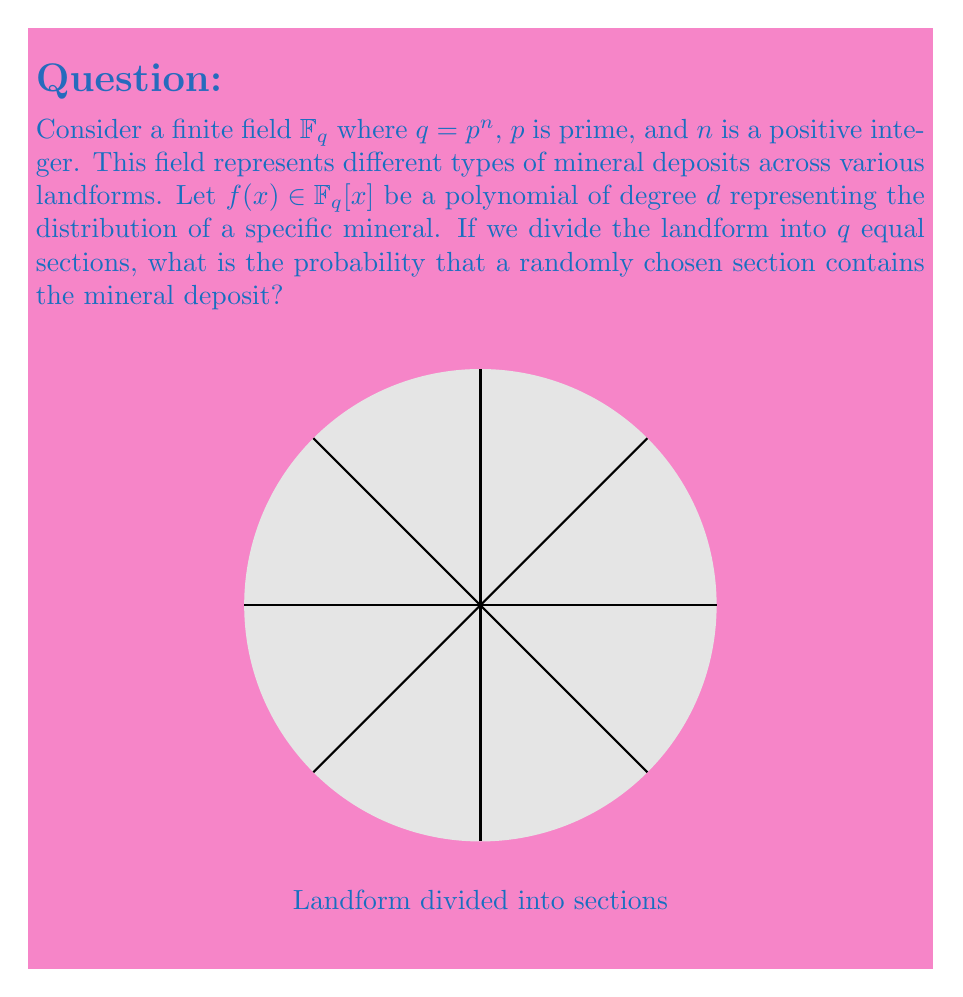Show me your answer to this math problem. To solve this problem, we'll use concepts from field theory and probability:

1) In a finite field $\mathbb{F}_q$, every element is a root of the polynomial $x^q - x$.

2) The polynomial $f(x)$ of degree $d$ can have at most $d$ roots in $\mathbb{F}_q$.

3) The number of elements in $\mathbb{F}_q$ that are not roots of $f(x)$ is at least $q - d$.

4) These non-root elements represent the sections of the landform where the mineral is present.

5) The probability of finding the mineral in a randomly chosen section is:

   $$P(\text{mineral present}) = \frac{\text{number of sections with mineral}}{\text{total number of sections}}$$

6) Using the results from steps 3 and 4:

   $$P(\text{mineral present}) \geq \frac{q - d}{q} = 1 - \frac{d}{q}$$

7) Therefore, the probability of finding the mineral in a randomly chosen section is at least $1 - \frac{d}{q}$.
Answer: $1 - \frac{d}{q}$ 